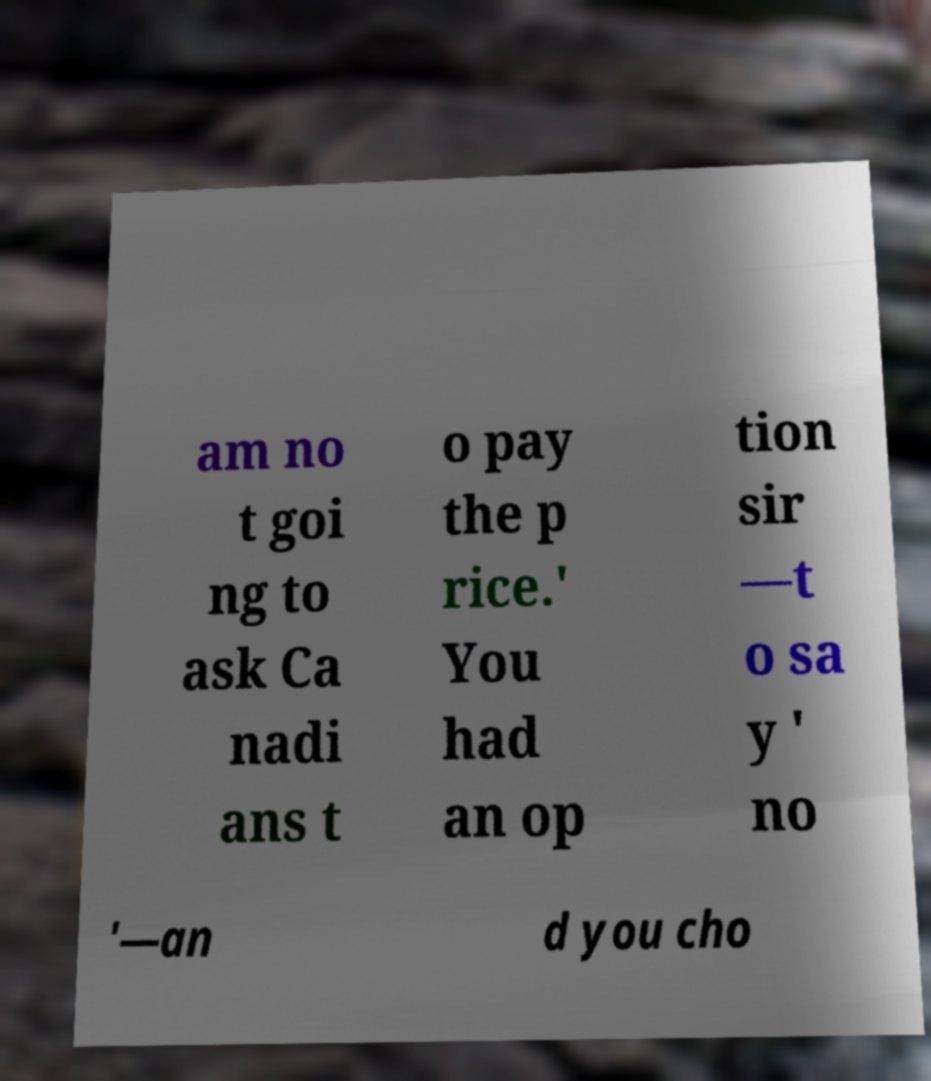What messages or text are displayed in this image? I need them in a readable, typed format. am no t goi ng to ask Ca nadi ans t o pay the p rice.' You had an op tion sir —t o sa y ' no '—an d you cho 